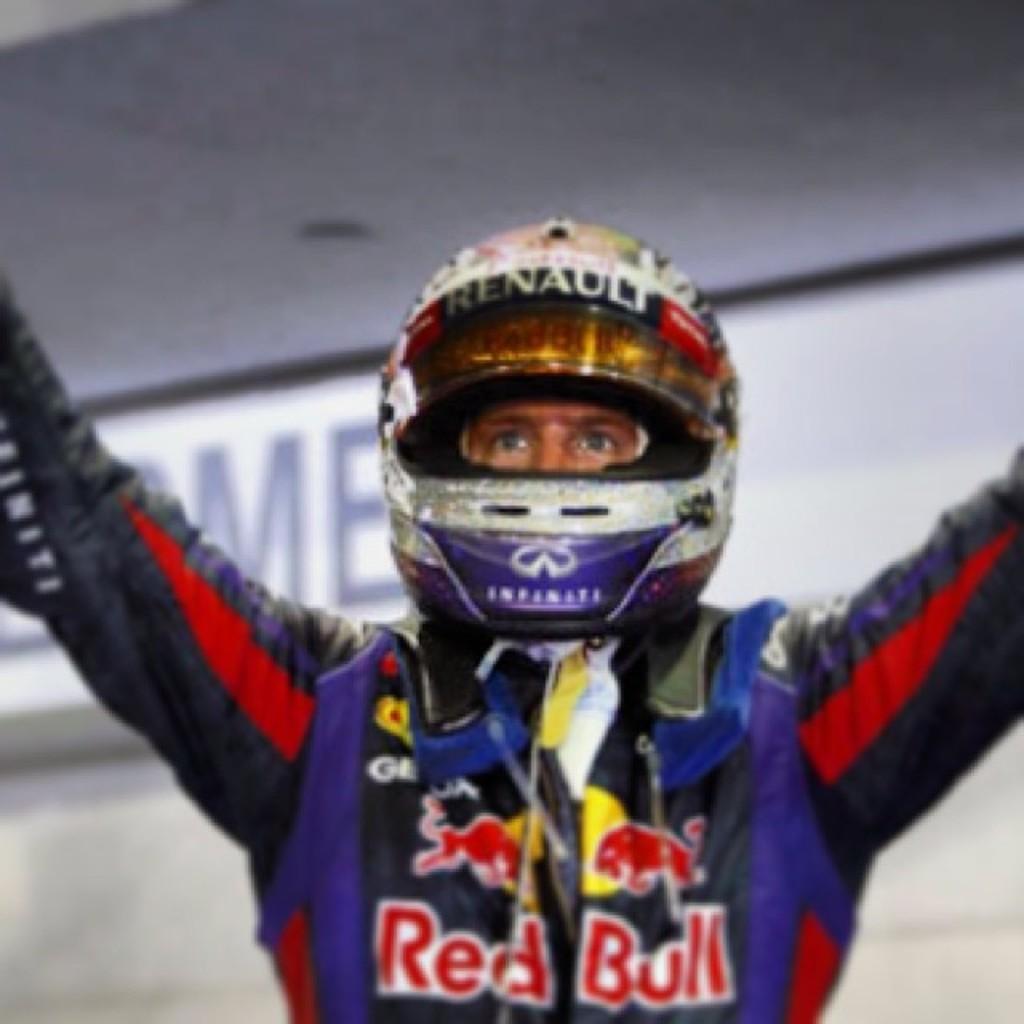Could you give a brief overview of what you see in this image? Background portion of the picture is blurry and we can see a board. In this picture we can see a person wearing a helmet. 